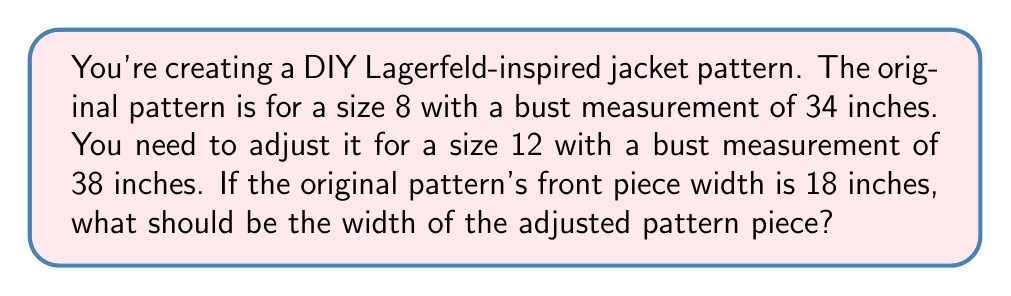Can you answer this question? Let's solve this step-by-step using proportions:

1) Set up the proportion:
   $\frac{\text{Original bust}}{\text{New bust}} = \frac{\text{Original width}}{\text{New width}}$

2) Plug in the known values:
   $\frac{34}{38} = \frac{18}{x}$

3) Cross multiply:
   $34x = 38 \cdot 18$

4) Simplify the right side:
   $34x = 684$

5) Divide both sides by 34:
   $x = \frac{684}{34}$

6) Simplify:
   $x = 20.12$

Therefore, the width of the adjusted pattern piece should be approximately 20.12 inches.
Answer: $20.12$ inches 